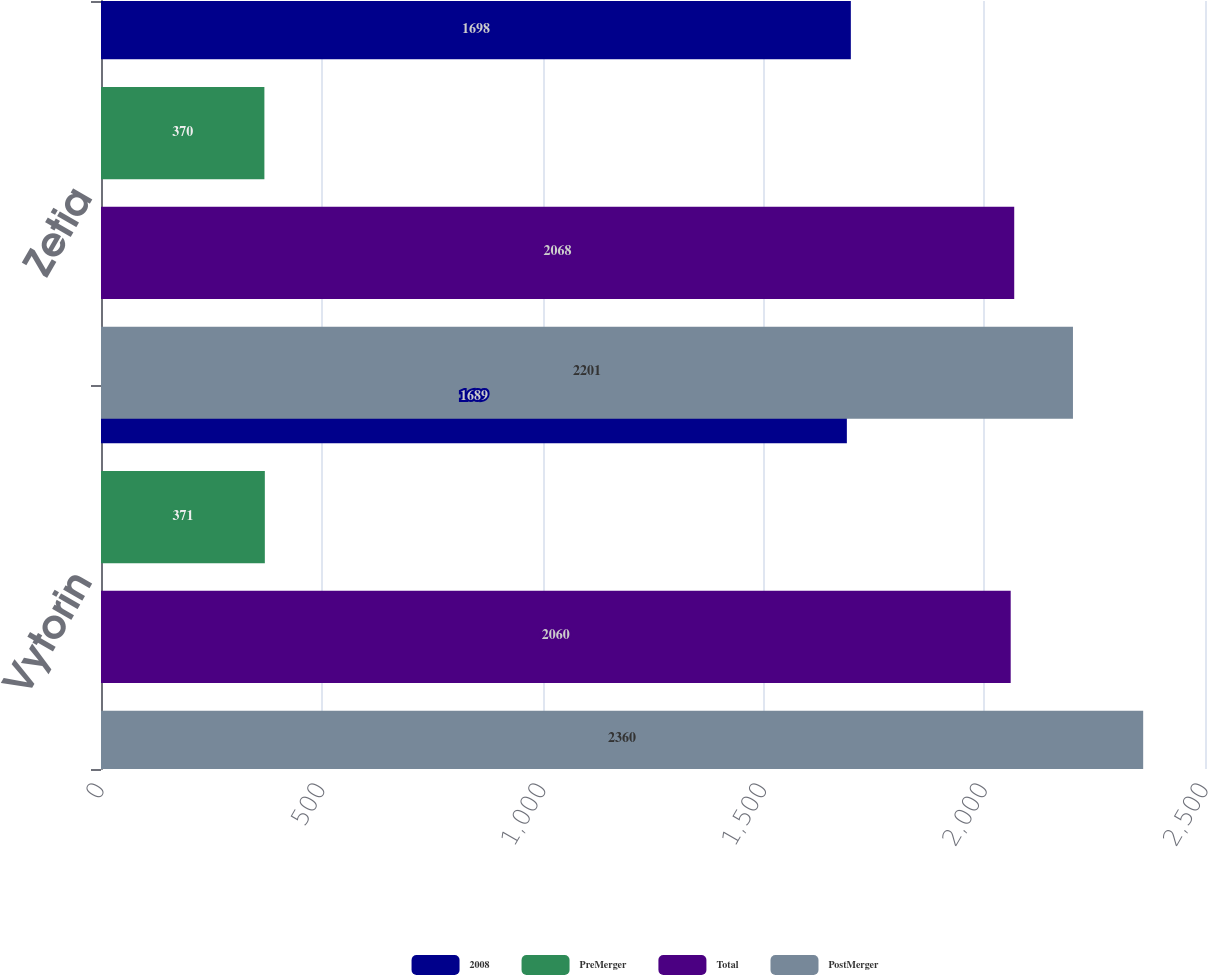Convert chart to OTSL. <chart><loc_0><loc_0><loc_500><loc_500><stacked_bar_chart><ecel><fcel>Vytorin<fcel>Zetia<nl><fcel>2008<fcel>1689<fcel>1698<nl><fcel>PreMerger<fcel>371<fcel>370<nl><fcel>Total<fcel>2060<fcel>2068<nl><fcel>PostMerger<fcel>2360<fcel>2201<nl></chart> 